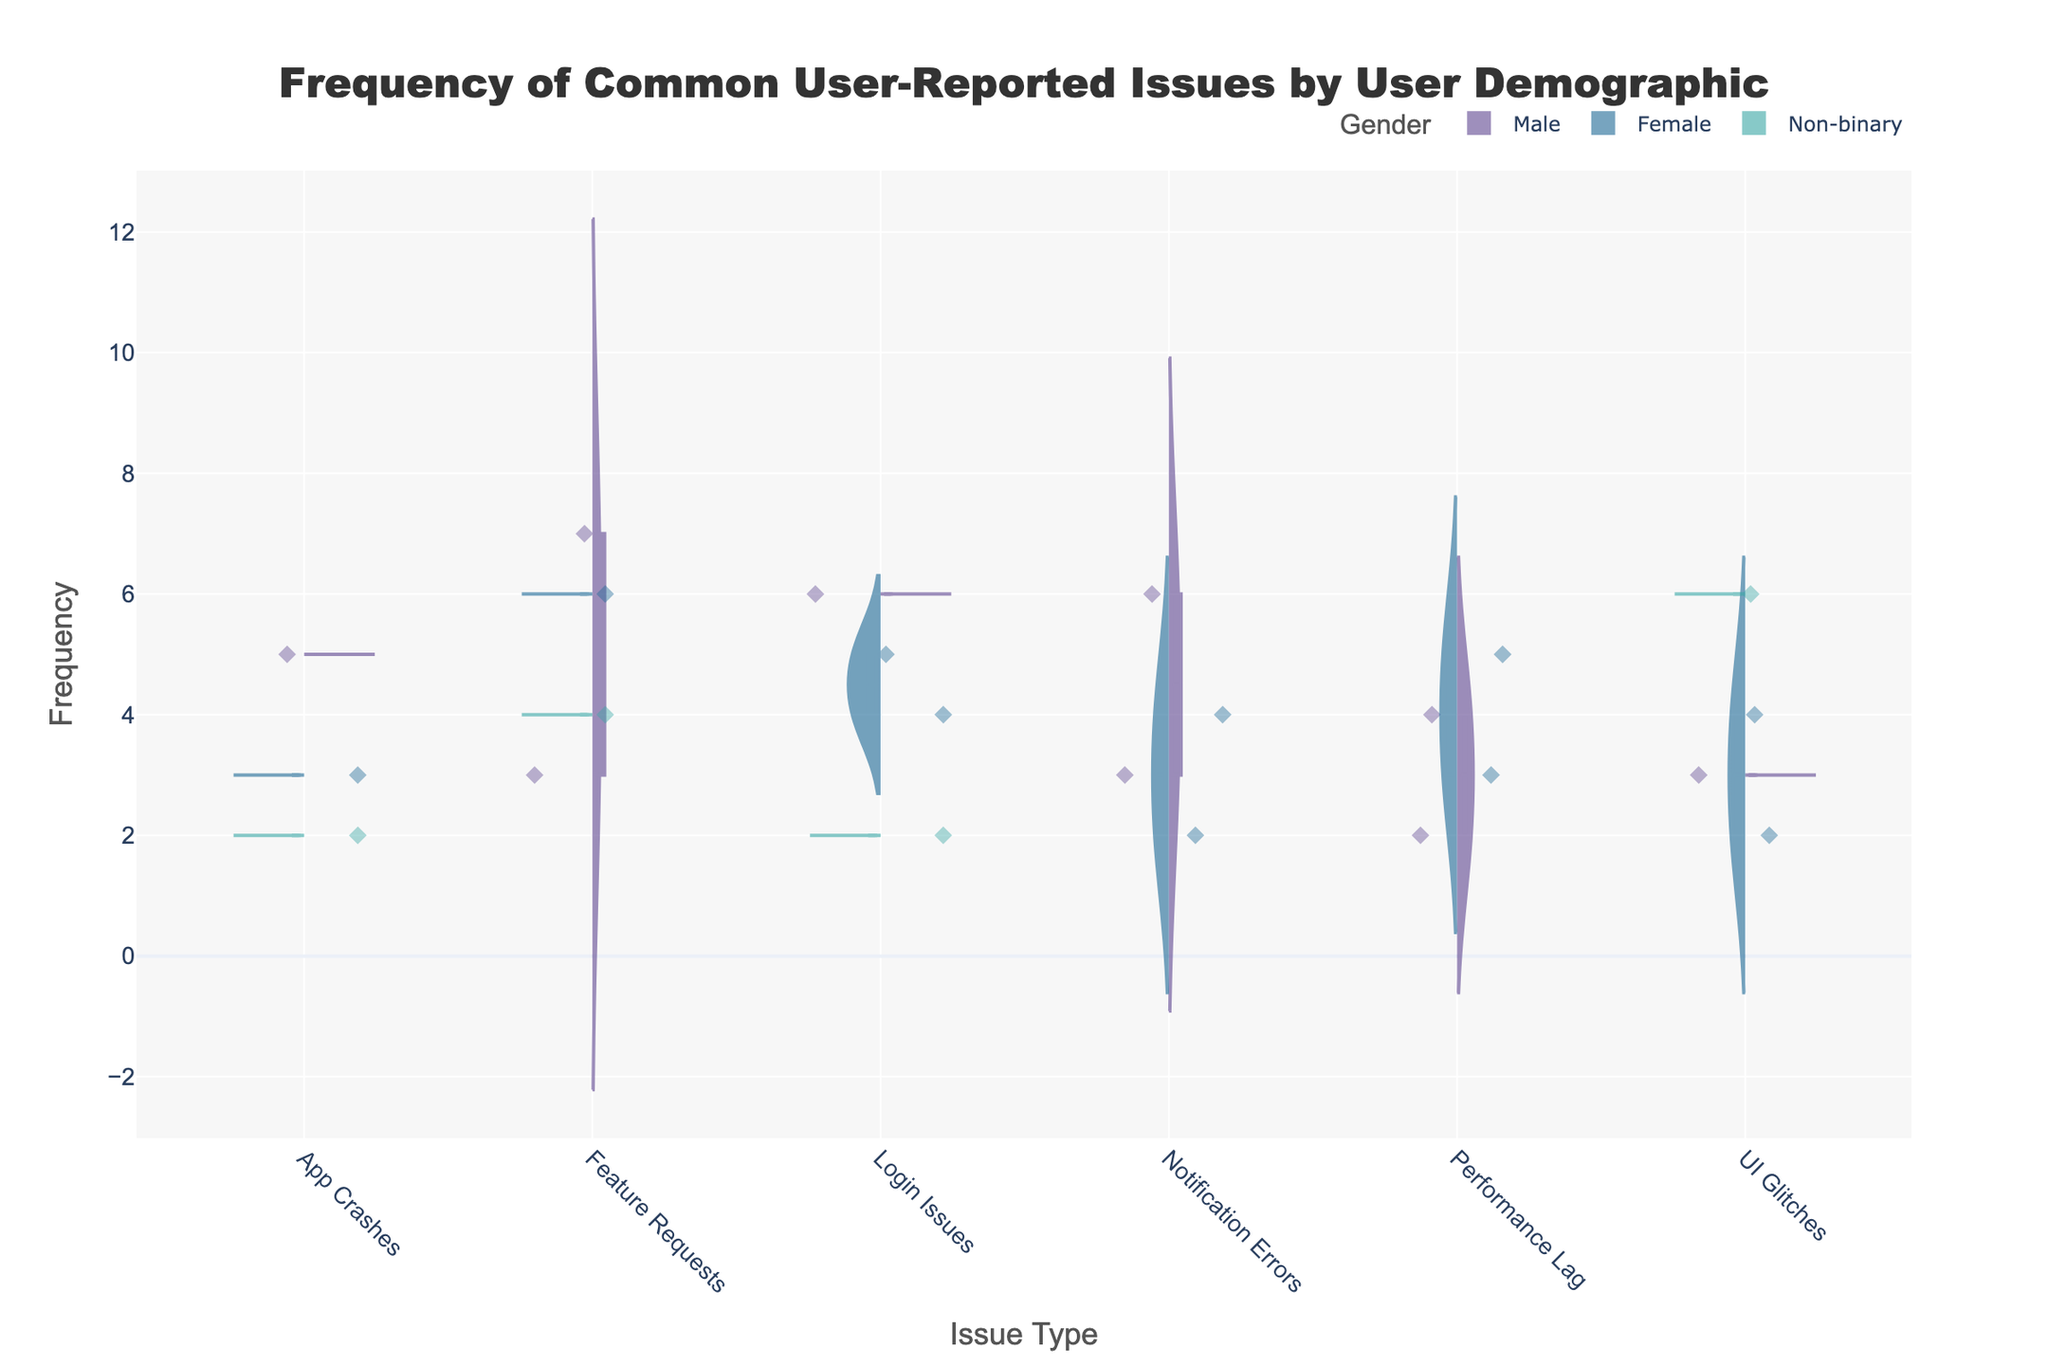What is the title of the figure? The title is typically displayed at the top center of the figure. In this case, it reads 'Frequency of Common User-Reported Issues by User Demographic'.
Answer: Frequency of Common User-Reported Issues by User Demographic What are the axes titles in the plot? The axes titles are usually found adjacent to the respective axes. The x-axis title reads 'Issue Type' and the y-axis title reads 'Frequency'.
Answer: Issue Type, Frequency Which gender reports the highest frequency of 'Feature Requests'? To find this, observe the split violin sections for 'Feature Requests'. The positive and negative sides next to different gender labels will indicate the frequency. The 'Male' gender shows the highest peak.
Answer: Male How does the frequency of 'Login Issues' differ for 'Male' and 'Non-binary' users? To compare, look at the frequency values for 'Login Issues' under both genders. 'Male' users have a higher frequency peak compared to 'Non-binary' users.
Answer: Male has higher frequency Are 'Notification Errors' more frequently reported by 'Female' or 'Male' users? By examining the split violins for 'Notification Errors', the peak for 'Male' users is higher than that for 'Female' users.
Answer: Male What is the average frequency of 'App Crashes' for all genders? First, look at the frequency points for 'App Crashes' which are 5 (Male), 3 (Female), and 2 (Non-binary). Add these values: 5 + 3 + 2 = 10. Then, divide by the number of entries (3): 10/3.
Answer: 3.33 Which issue type shows the most significant gender-based frequency difference? Reviewing the overall spread and length of the split violins across genders can reveal the largest difference. 'Feature Requests' has a significant contrast, especially between 'Male' and other genders.
Answer: Feature Requests How many unique issue types are represented in the plot? Count the categories on the x-axis, which are 'App Crashes', 'Login Issues', 'Notification Errors', 'Performance Lag', 'UI Glitches', and 'Feature Requests'.
Answer: 6 Is 'UI Glitches' more frequently reported by 'Non-binary' users or 'Female' users? Compare the split violin sections for 'UI Glitches'. 'Non-binary' users have a higher frequency peak compared to 'Female' users.
Answer: Non-binary 